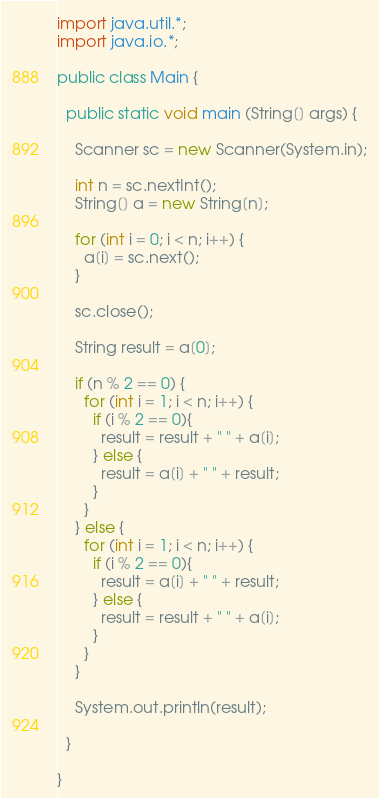Convert code to text. <code><loc_0><loc_0><loc_500><loc_500><_Java_>import java.util.*;
import java.io.*;

public class Main {

  public static void main (String[] args) {

    Scanner sc = new Scanner(System.in);
    
    int n = sc.nextInt();
    String[] a = new String[n];

    for (int i = 0; i < n; i++) {
      a[i] = sc.next();
    }

    sc.close();

    String result = a[0];

    if (n % 2 == 0) {
      for (int i = 1; i < n; i++) {
        if (i % 2 == 0){
          result = result + " " + a[i];
        } else {
          result = a[i] + " " + result;
        }
      }
    } else {
      for (int i = 1; i < n; i++) {
        if (i % 2 == 0){
          result = a[i] + " " + result;
        } else {
          result = result + " " + a[i];
        }
      }
    }
    
    System.out.println(result);

  }

}
</code> 